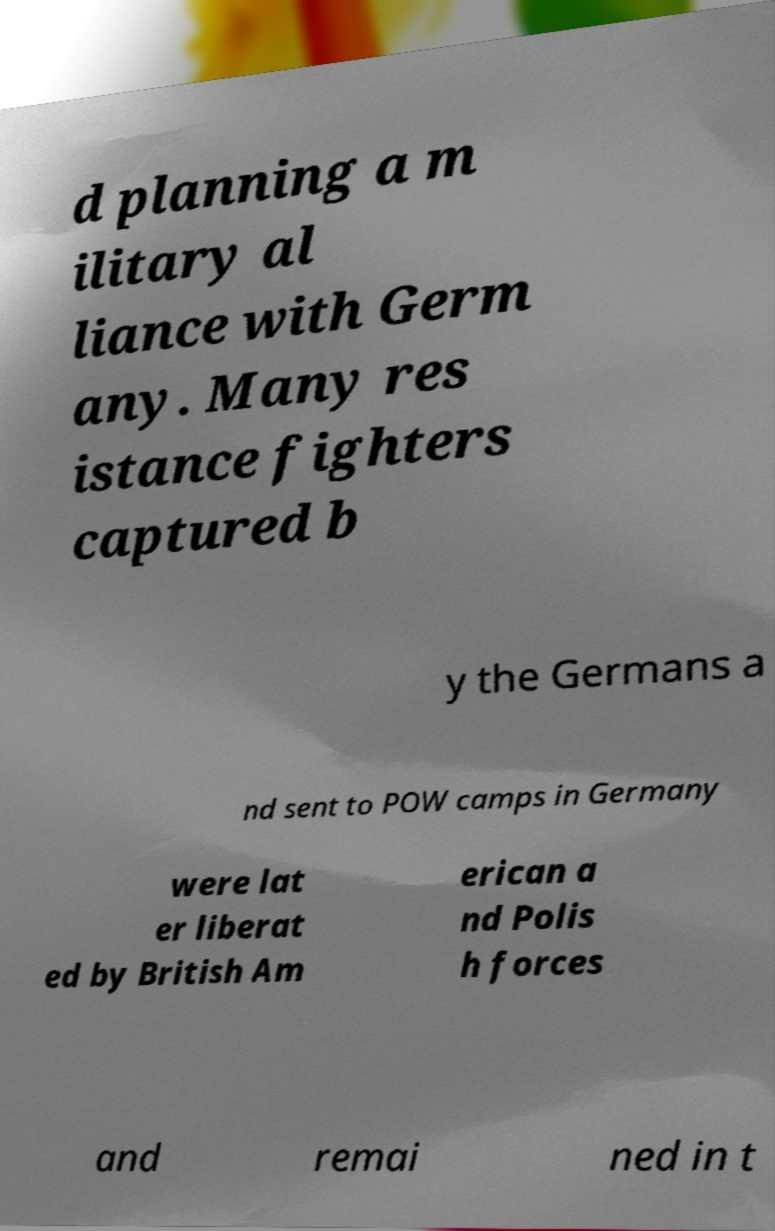Please identify and transcribe the text found in this image. d planning a m ilitary al liance with Germ any. Many res istance fighters captured b y the Germans a nd sent to POW camps in Germany were lat er liberat ed by British Am erican a nd Polis h forces and remai ned in t 